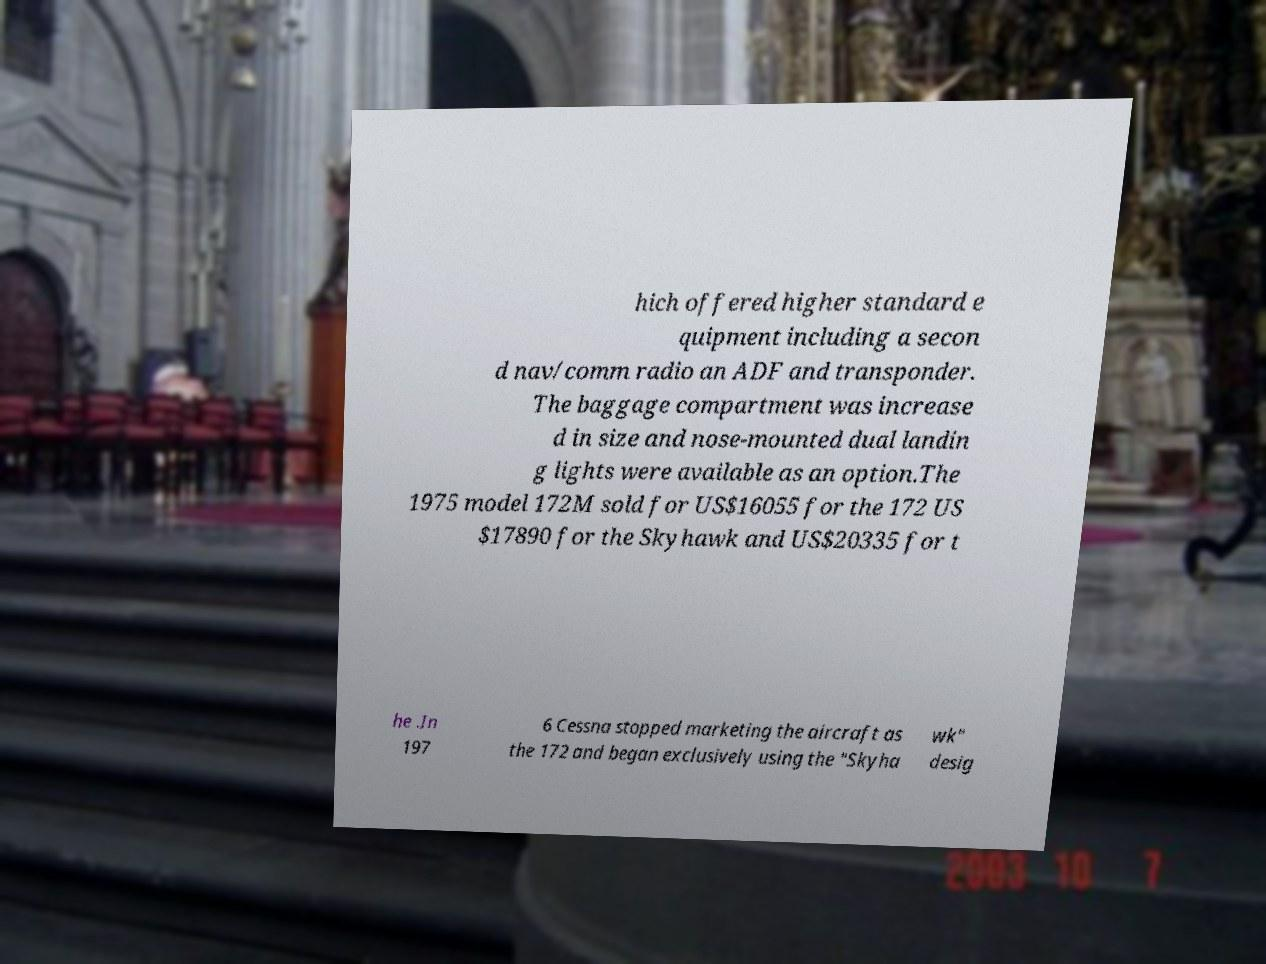Please read and relay the text visible in this image. What does it say? hich offered higher standard e quipment including a secon d nav/comm radio an ADF and transponder. The baggage compartment was increase d in size and nose-mounted dual landin g lights were available as an option.The 1975 model 172M sold for US$16055 for the 172 US $17890 for the Skyhawk and US$20335 for t he .In 197 6 Cessna stopped marketing the aircraft as the 172 and began exclusively using the "Skyha wk" desig 